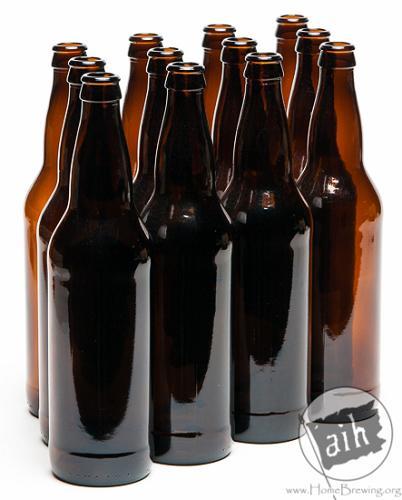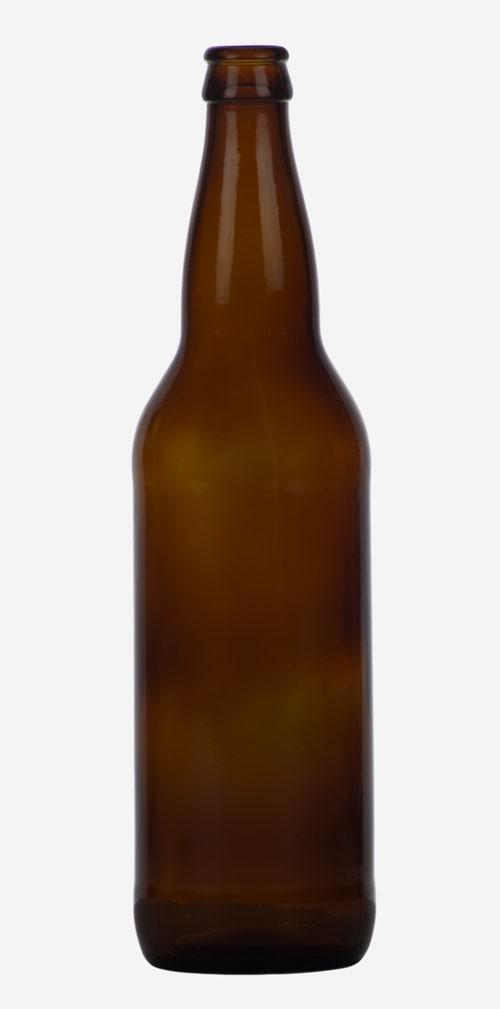The first image is the image on the left, the second image is the image on the right. Considering the images on both sides, is "One image shows rows of four bottles three deep." valid? Answer yes or no. Yes. 